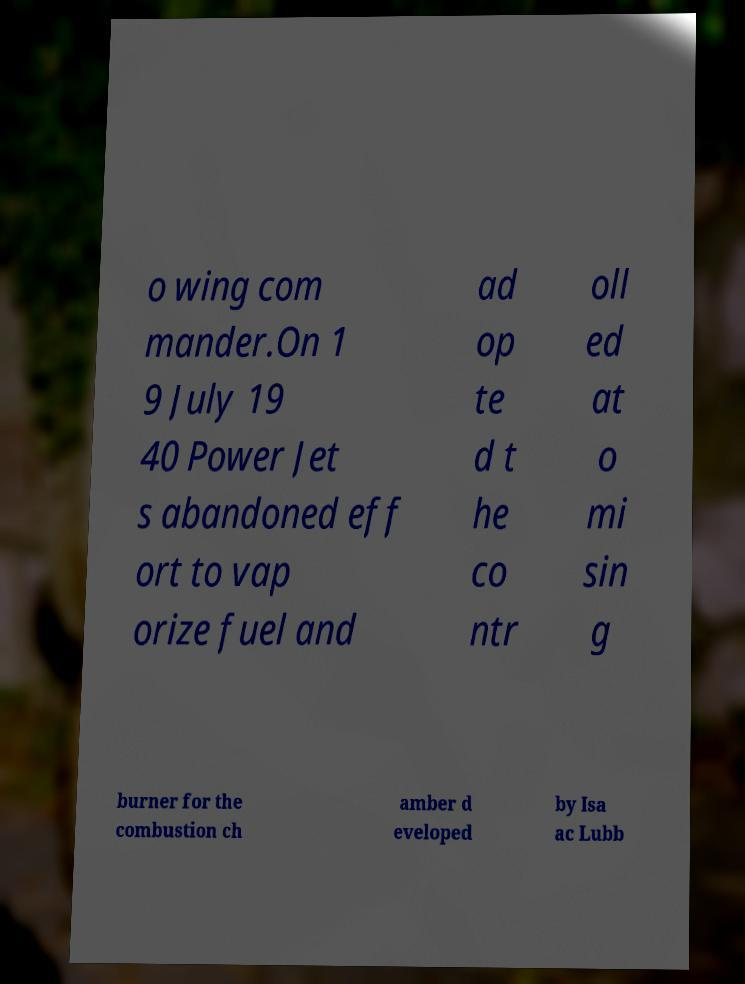What messages or text are displayed in this image? I need them in a readable, typed format. o wing com mander.On 1 9 July 19 40 Power Jet s abandoned eff ort to vap orize fuel and ad op te d t he co ntr oll ed at o mi sin g burner for the combustion ch amber d eveloped by Isa ac Lubb 